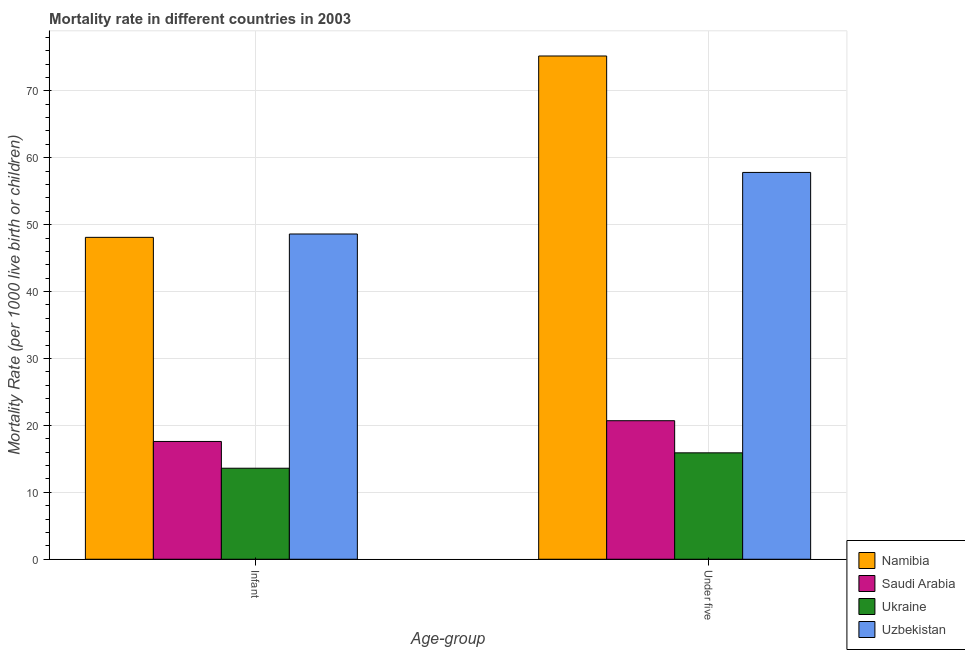How many different coloured bars are there?
Provide a short and direct response. 4. How many groups of bars are there?
Your response must be concise. 2. Are the number of bars per tick equal to the number of legend labels?
Ensure brevity in your answer.  Yes. How many bars are there on the 2nd tick from the left?
Provide a short and direct response. 4. How many bars are there on the 2nd tick from the right?
Give a very brief answer. 4. What is the label of the 2nd group of bars from the left?
Your answer should be compact. Under five. What is the under-5 mortality rate in Ukraine?
Keep it short and to the point. 15.9. Across all countries, what is the maximum infant mortality rate?
Offer a terse response. 48.6. In which country was the under-5 mortality rate maximum?
Your answer should be compact. Namibia. In which country was the under-5 mortality rate minimum?
Provide a short and direct response. Ukraine. What is the total under-5 mortality rate in the graph?
Offer a terse response. 169.6. What is the difference between the under-5 mortality rate in Namibia and that in Uzbekistan?
Give a very brief answer. 17.4. What is the difference between the infant mortality rate in Saudi Arabia and the under-5 mortality rate in Namibia?
Your response must be concise. -57.6. What is the average infant mortality rate per country?
Your answer should be compact. 31.98. What is the difference between the infant mortality rate and under-5 mortality rate in Saudi Arabia?
Provide a short and direct response. -3.1. What is the ratio of the under-5 mortality rate in Uzbekistan to that in Namibia?
Provide a short and direct response. 0.77. Is the under-5 mortality rate in Uzbekistan less than that in Namibia?
Provide a short and direct response. Yes. What does the 2nd bar from the left in Under five represents?
Keep it short and to the point. Saudi Arabia. What does the 3rd bar from the right in Infant represents?
Keep it short and to the point. Saudi Arabia. How many bars are there?
Keep it short and to the point. 8. Are all the bars in the graph horizontal?
Keep it short and to the point. No. How many countries are there in the graph?
Your answer should be very brief. 4. What is the difference between two consecutive major ticks on the Y-axis?
Keep it short and to the point. 10. Are the values on the major ticks of Y-axis written in scientific E-notation?
Your answer should be very brief. No. Does the graph contain any zero values?
Your response must be concise. No. Does the graph contain grids?
Offer a terse response. Yes. Where does the legend appear in the graph?
Your answer should be compact. Bottom right. How many legend labels are there?
Offer a very short reply. 4. How are the legend labels stacked?
Offer a very short reply. Vertical. What is the title of the graph?
Make the answer very short. Mortality rate in different countries in 2003. Does "Czech Republic" appear as one of the legend labels in the graph?
Offer a very short reply. No. What is the label or title of the X-axis?
Your answer should be very brief. Age-group. What is the label or title of the Y-axis?
Provide a succinct answer. Mortality Rate (per 1000 live birth or children). What is the Mortality Rate (per 1000 live birth or children) in Namibia in Infant?
Keep it short and to the point. 48.1. What is the Mortality Rate (per 1000 live birth or children) of Saudi Arabia in Infant?
Offer a very short reply. 17.6. What is the Mortality Rate (per 1000 live birth or children) of Uzbekistan in Infant?
Ensure brevity in your answer.  48.6. What is the Mortality Rate (per 1000 live birth or children) in Namibia in Under five?
Your answer should be compact. 75.2. What is the Mortality Rate (per 1000 live birth or children) in Saudi Arabia in Under five?
Keep it short and to the point. 20.7. What is the Mortality Rate (per 1000 live birth or children) in Uzbekistan in Under five?
Offer a very short reply. 57.8. Across all Age-group, what is the maximum Mortality Rate (per 1000 live birth or children) of Namibia?
Make the answer very short. 75.2. Across all Age-group, what is the maximum Mortality Rate (per 1000 live birth or children) of Saudi Arabia?
Your answer should be very brief. 20.7. Across all Age-group, what is the maximum Mortality Rate (per 1000 live birth or children) in Ukraine?
Make the answer very short. 15.9. Across all Age-group, what is the maximum Mortality Rate (per 1000 live birth or children) in Uzbekistan?
Provide a succinct answer. 57.8. Across all Age-group, what is the minimum Mortality Rate (per 1000 live birth or children) of Namibia?
Give a very brief answer. 48.1. Across all Age-group, what is the minimum Mortality Rate (per 1000 live birth or children) in Uzbekistan?
Provide a short and direct response. 48.6. What is the total Mortality Rate (per 1000 live birth or children) in Namibia in the graph?
Make the answer very short. 123.3. What is the total Mortality Rate (per 1000 live birth or children) of Saudi Arabia in the graph?
Offer a terse response. 38.3. What is the total Mortality Rate (per 1000 live birth or children) of Ukraine in the graph?
Ensure brevity in your answer.  29.5. What is the total Mortality Rate (per 1000 live birth or children) of Uzbekistan in the graph?
Provide a short and direct response. 106.4. What is the difference between the Mortality Rate (per 1000 live birth or children) in Namibia in Infant and that in Under five?
Your answer should be very brief. -27.1. What is the difference between the Mortality Rate (per 1000 live birth or children) of Uzbekistan in Infant and that in Under five?
Your answer should be compact. -9.2. What is the difference between the Mortality Rate (per 1000 live birth or children) of Namibia in Infant and the Mortality Rate (per 1000 live birth or children) of Saudi Arabia in Under five?
Offer a very short reply. 27.4. What is the difference between the Mortality Rate (per 1000 live birth or children) of Namibia in Infant and the Mortality Rate (per 1000 live birth or children) of Ukraine in Under five?
Your answer should be compact. 32.2. What is the difference between the Mortality Rate (per 1000 live birth or children) in Saudi Arabia in Infant and the Mortality Rate (per 1000 live birth or children) in Ukraine in Under five?
Provide a short and direct response. 1.7. What is the difference between the Mortality Rate (per 1000 live birth or children) of Saudi Arabia in Infant and the Mortality Rate (per 1000 live birth or children) of Uzbekistan in Under five?
Your response must be concise. -40.2. What is the difference between the Mortality Rate (per 1000 live birth or children) of Ukraine in Infant and the Mortality Rate (per 1000 live birth or children) of Uzbekistan in Under five?
Offer a terse response. -44.2. What is the average Mortality Rate (per 1000 live birth or children) in Namibia per Age-group?
Your answer should be compact. 61.65. What is the average Mortality Rate (per 1000 live birth or children) of Saudi Arabia per Age-group?
Your answer should be very brief. 19.15. What is the average Mortality Rate (per 1000 live birth or children) in Ukraine per Age-group?
Your response must be concise. 14.75. What is the average Mortality Rate (per 1000 live birth or children) of Uzbekistan per Age-group?
Offer a terse response. 53.2. What is the difference between the Mortality Rate (per 1000 live birth or children) in Namibia and Mortality Rate (per 1000 live birth or children) in Saudi Arabia in Infant?
Offer a very short reply. 30.5. What is the difference between the Mortality Rate (per 1000 live birth or children) of Namibia and Mortality Rate (per 1000 live birth or children) of Ukraine in Infant?
Ensure brevity in your answer.  34.5. What is the difference between the Mortality Rate (per 1000 live birth or children) in Saudi Arabia and Mortality Rate (per 1000 live birth or children) in Uzbekistan in Infant?
Provide a succinct answer. -31. What is the difference between the Mortality Rate (per 1000 live birth or children) of Ukraine and Mortality Rate (per 1000 live birth or children) of Uzbekistan in Infant?
Ensure brevity in your answer.  -35. What is the difference between the Mortality Rate (per 1000 live birth or children) in Namibia and Mortality Rate (per 1000 live birth or children) in Saudi Arabia in Under five?
Keep it short and to the point. 54.5. What is the difference between the Mortality Rate (per 1000 live birth or children) in Namibia and Mortality Rate (per 1000 live birth or children) in Ukraine in Under five?
Ensure brevity in your answer.  59.3. What is the difference between the Mortality Rate (per 1000 live birth or children) of Saudi Arabia and Mortality Rate (per 1000 live birth or children) of Uzbekistan in Under five?
Your answer should be very brief. -37.1. What is the difference between the Mortality Rate (per 1000 live birth or children) of Ukraine and Mortality Rate (per 1000 live birth or children) of Uzbekistan in Under five?
Offer a very short reply. -41.9. What is the ratio of the Mortality Rate (per 1000 live birth or children) in Namibia in Infant to that in Under five?
Your response must be concise. 0.64. What is the ratio of the Mortality Rate (per 1000 live birth or children) of Saudi Arabia in Infant to that in Under five?
Ensure brevity in your answer.  0.85. What is the ratio of the Mortality Rate (per 1000 live birth or children) in Ukraine in Infant to that in Under five?
Give a very brief answer. 0.86. What is the ratio of the Mortality Rate (per 1000 live birth or children) of Uzbekistan in Infant to that in Under five?
Make the answer very short. 0.84. What is the difference between the highest and the second highest Mortality Rate (per 1000 live birth or children) of Namibia?
Ensure brevity in your answer.  27.1. What is the difference between the highest and the lowest Mortality Rate (per 1000 live birth or children) in Namibia?
Make the answer very short. 27.1. What is the difference between the highest and the lowest Mortality Rate (per 1000 live birth or children) in Saudi Arabia?
Your response must be concise. 3.1. What is the difference between the highest and the lowest Mortality Rate (per 1000 live birth or children) of Uzbekistan?
Provide a succinct answer. 9.2. 